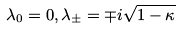<formula> <loc_0><loc_0><loc_500><loc_500>\lambda _ { 0 } = 0 , \lambda _ { \pm } = \mp i \sqrt { 1 - \kappa }</formula> 